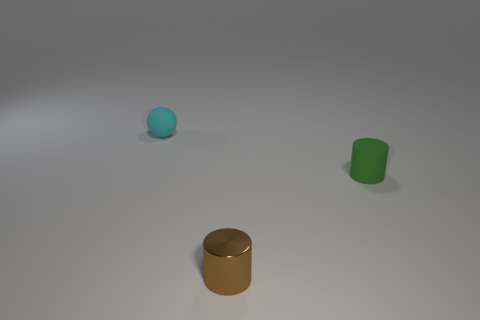Add 3 brown spheres. How many objects exist? 6 Subtract all cylinders. How many objects are left? 1 Subtract 0 purple cylinders. How many objects are left? 3 Subtract all brown metallic objects. Subtract all green cylinders. How many objects are left? 1 Add 2 rubber cylinders. How many rubber cylinders are left? 3 Add 1 matte things. How many matte things exist? 3 